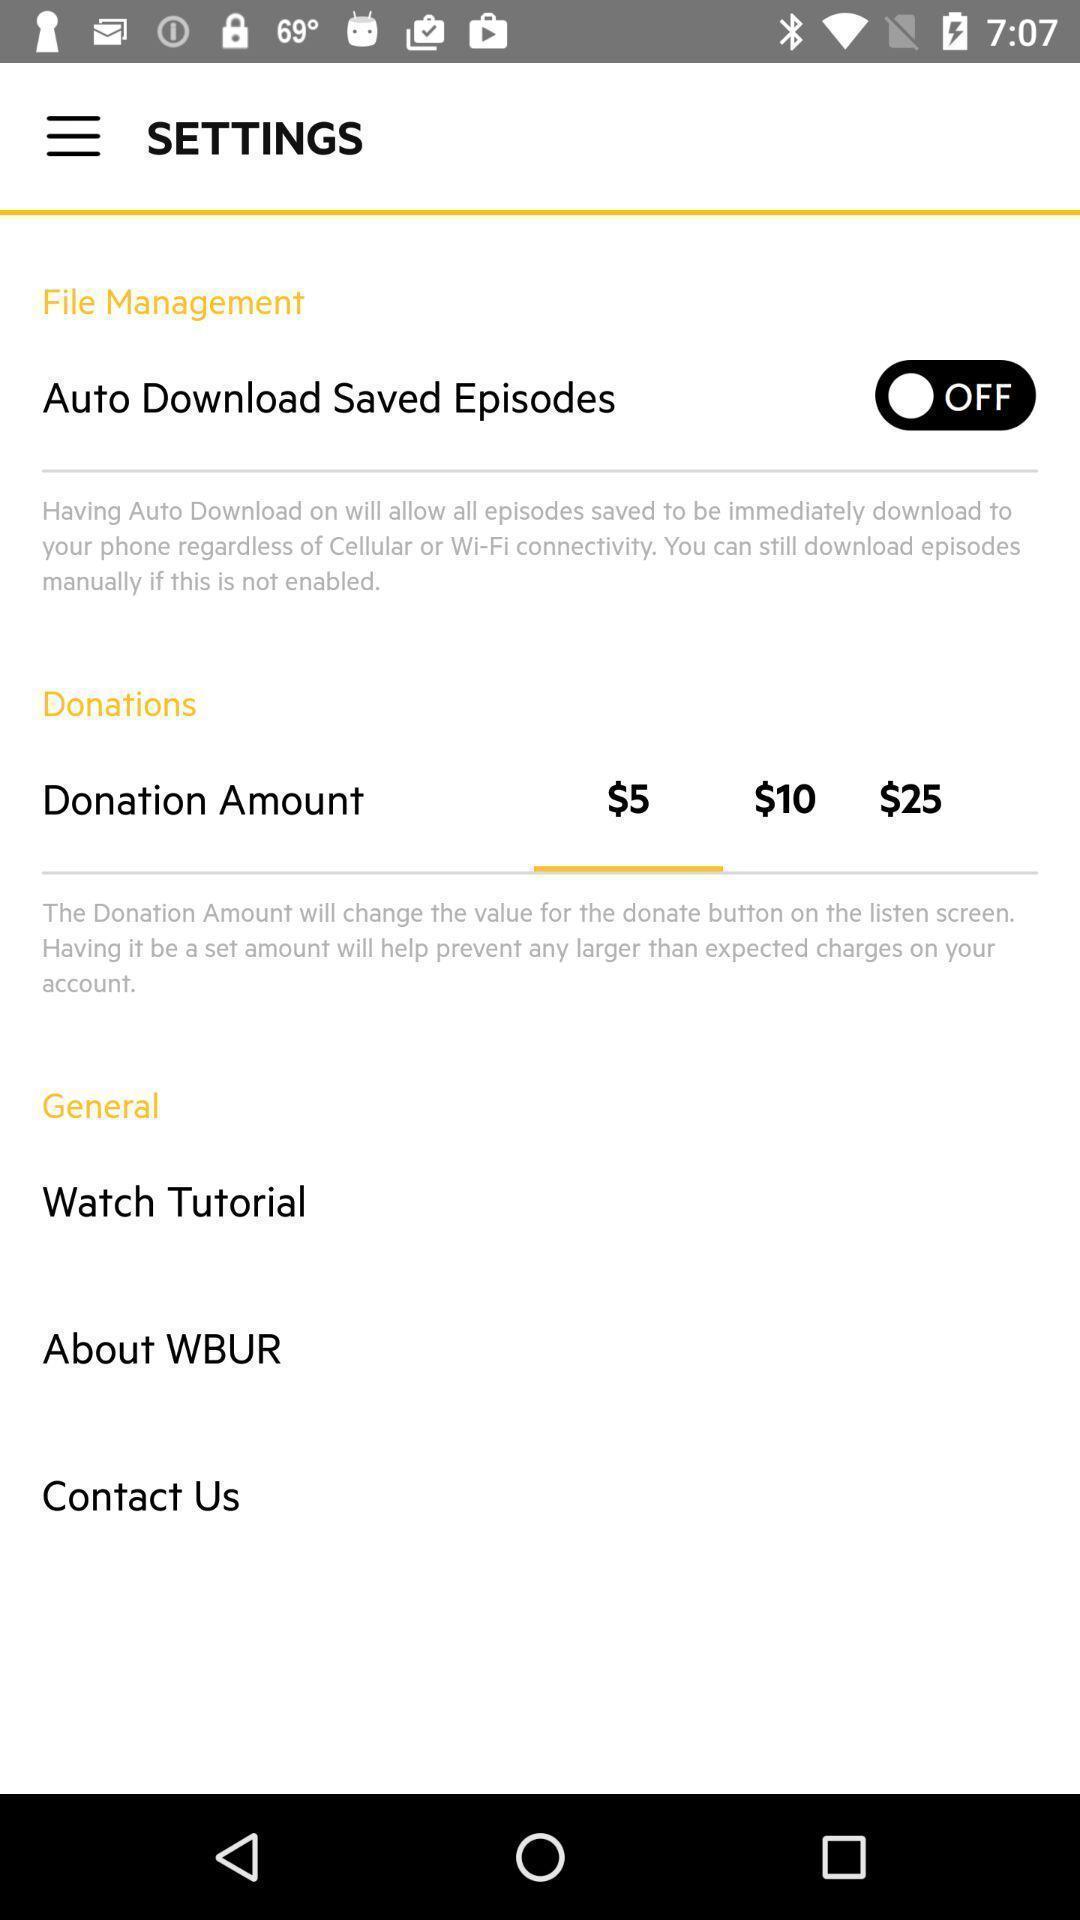Tell me what you see in this picture. Settings tab with different options in the application. 